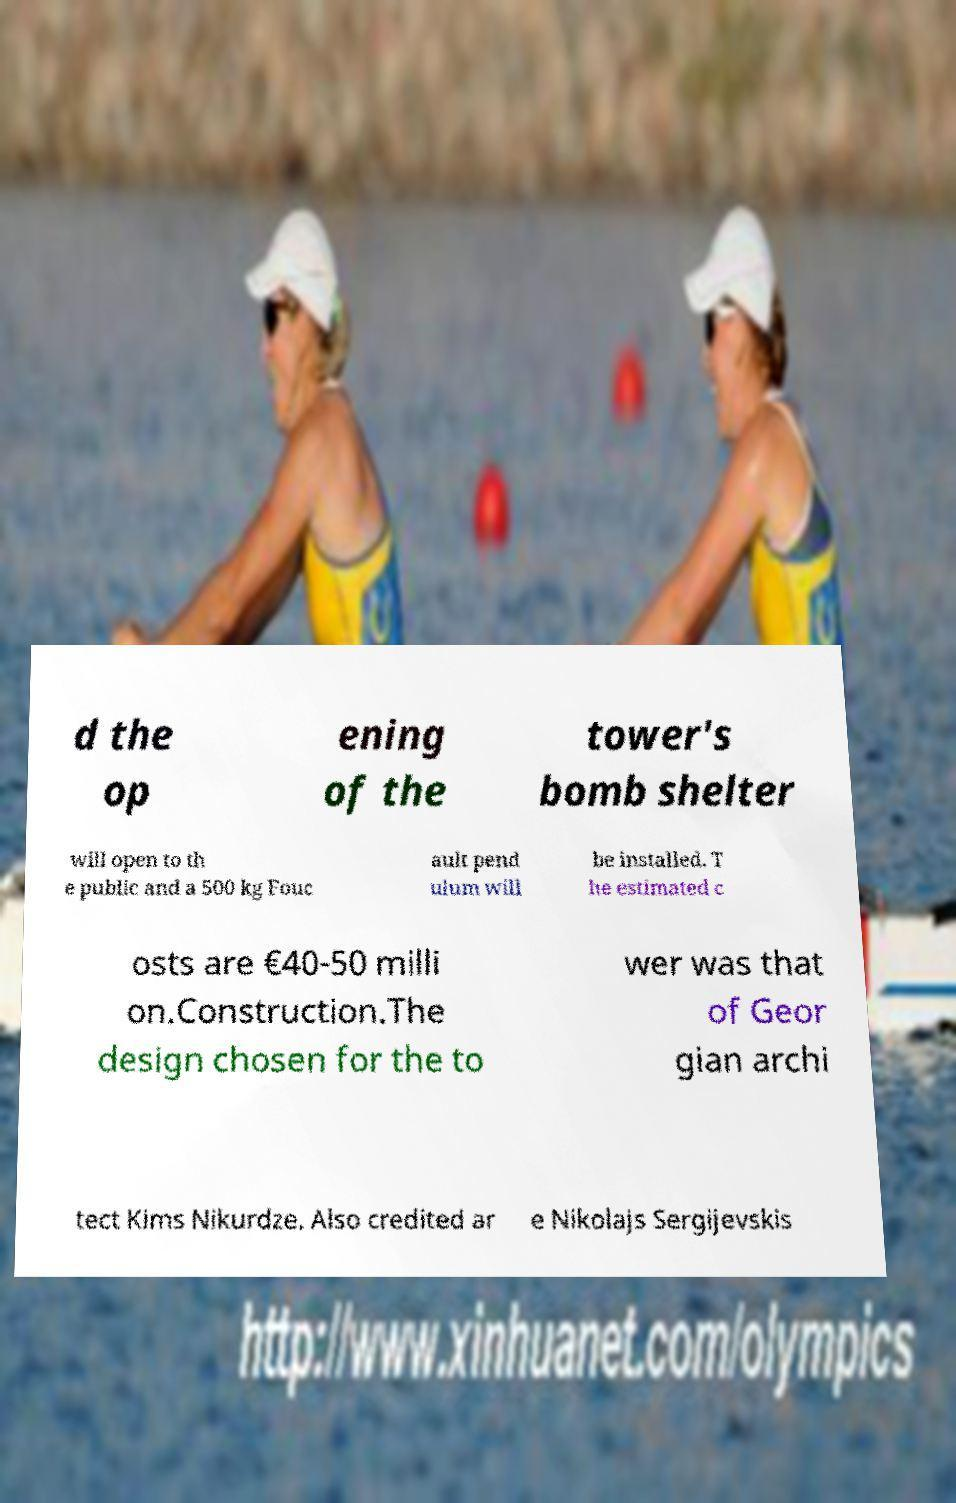There's text embedded in this image that I need extracted. Can you transcribe it verbatim? d the op ening of the tower's bomb shelter will open to th e public and a 500 kg Fouc ault pend ulum will be installed. T he estimated c osts are €40-50 milli on.Construction.The design chosen for the to wer was that of Geor gian archi tect Kims Nikurdze. Also credited ar e Nikolajs Sergijevskis 